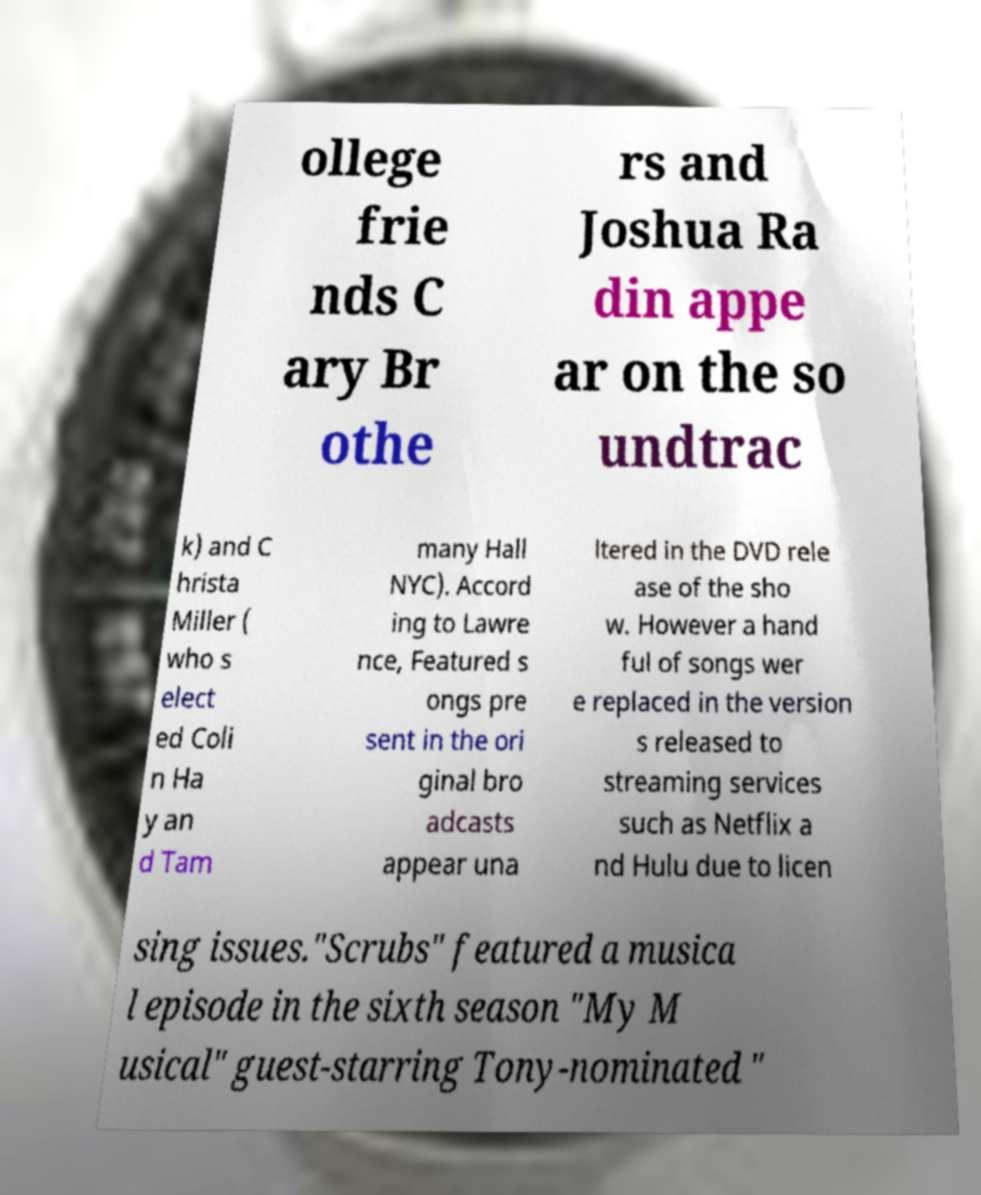What messages or text are displayed in this image? I need them in a readable, typed format. ollege frie nds C ary Br othe rs and Joshua Ra din appe ar on the so undtrac k) and C hrista Miller ( who s elect ed Coli n Ha y an d Tam many Hall NYC). Accord ing to Lawre nce, Featured s ongs pre sent in the ori ginal bro adcasts appear una ltered in the DVD rele ase of the sho w. However a hand ful of songs wer e replaced in the version s released to streaming services such as Netflix a nd Hulu due to licen sing issues."Scrubs" featured a musica l episode in the sixth season "My M usical" guest-starring Tony-nominated " 